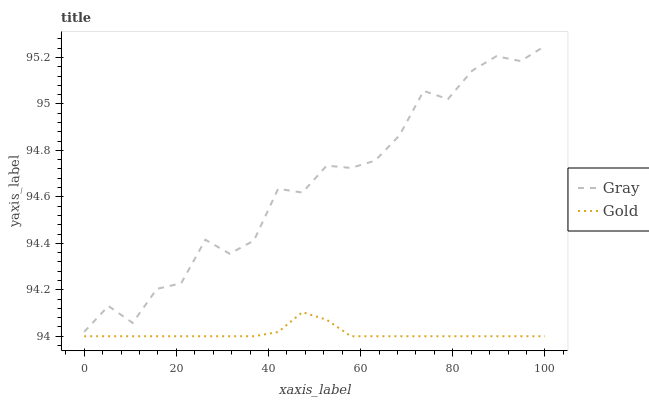Does Gold have the minimum area under the curve?
Answer yes or no. Yes. Does Gold have the maximum area under the curve?
Answer yes or no. No. Is Gold the roughest?
Answer yes or no. No. Does Gold have the highest value?
Answer yes or no. No. Is Gold less than Gray?
Answer yes or no. Yes. Is Gray greater than Gold?
Answer yes or no. Yes. Does Gold intersect Gray?
Answer yes or no. No. 